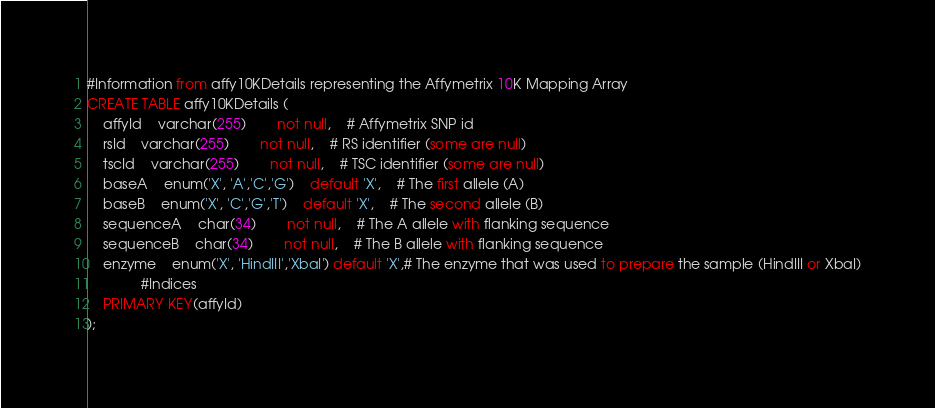Convert code to text. <code><loc_0><loc_0><loc_500><loc_500><_SQL_>#Information from affy10KDetails representing the Affymetrix 10K Mapping Array
CREATE TABLE affy10KDetails (
    affyId 	varchar(255) 		not null,	# Affymetrix SNP id
    rsId 	varchar(255) 		not null,	# RS identifier (some are null)
    tscId 	varchar(255) 		not null,	# TSC identifier (some are null)
    baseA 	enum('X', 'A','C','G') 	default 'X',	# The first allele (A)
    baseB 	enum('X', 'C','G','T') 	default 'X',	# The second allele (B)
    sequenceA 	char(34) 		not null,	# The A allele with flanking sequence
    sequenceB 	char(34) 		not null,	# The B allele with flanking sequence
    enzyme  	enum('X', 'HindIII','XbaI') default 'X',# The enzyme that was used to prepare the sample (HindIII or XbaI)
              #Indices
    PRIMARY KEY(affyId)
);
</code> 